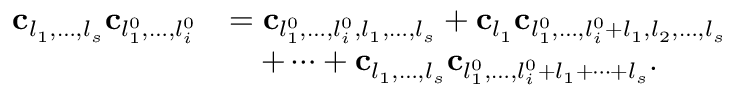<formula> <loc_0><loc_0><loc_500><loc_500>\begin{array} { r l } { c _ { l _ { 1 } , \dots , l _ { s } } c _ { l _ { 1 } ^ { 0 } , \dots , l _ { i } ^ { 0 } } } & { = c _ { l _ { 1 } ^ { 0 } , \dots , l _ { i } ^ { 0 } , l _ { 1 } , \dots , l _ { s } } + c _ { l _ { 1 } } c _ { l _ { 1 } ^ { 0 } , \dots , l _ { i } ^ { 0 } + l _ { 1 } , l _ { 2 } , \dots , l _ { s } } } \\ & { \quad + \cdots + c _ { l _ { 1 } , \dots , l _ { s } } c _ { l _ { 1 } ^ { 0 } , \dots , l _ { i } ^ { 0 } + l _ { 1 } + \cdots + l _ { s } } . } \end{array}</formula> 